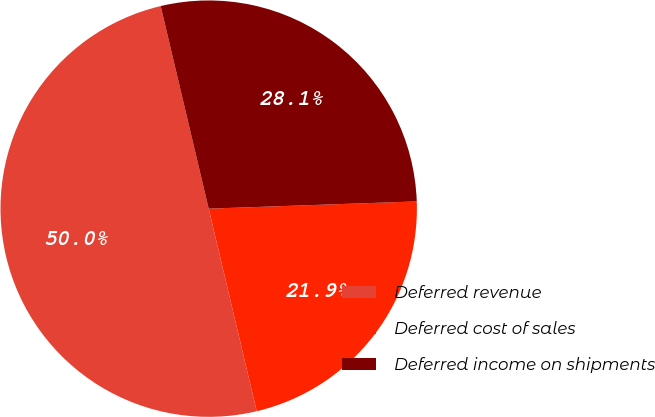<chart> <loc_0><loc_0><loc_500><loc_500><pie_chart><fcel>Deferred revenue<fcel>Deferred cost of sales<fcel>Deferred income on shipments<nl><fcel>50.0%<fcel>21.85%<fcel>28.15%<nl></chart> 